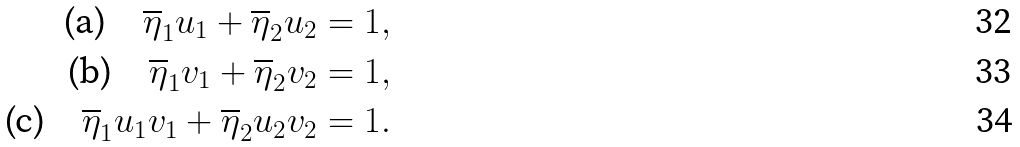Convert formula to latex. <formula><loc_0><loc_0><loc_500><loc_500>\text {(a)} \quad \overline { \eta } _ { 1 } u _ { 1 } + \overline { \eta } _ { 2 } u _ { 2 } = 1 , \\ \text {(b)} \quad \overline { \eta } _ { 1 } v _ { 1 } + \overline { \eta } _ { 2 } v _ { 2 } = 1 , \\ \text {(c)} \quad \overline { \eta } _ { 1 } u _ { 1 } v _ { 1 } + \overline { \eta } _ { 2 } u _ { 2 } v _ { 2 } = 1 .</formula> 